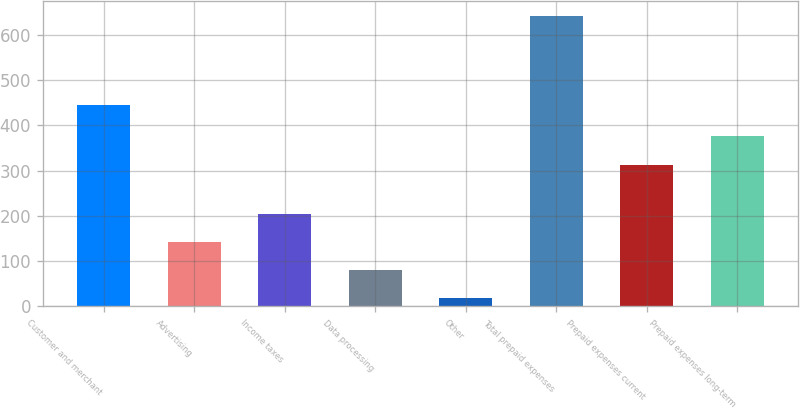<chart> <loc_0><loc_0><loc_500><loc_500><bar_chart><fcel>Customer and merchant<fcel>Advertising<fcel>Income taxes<fcel>Data processing<fcel>Other<fcel>Total prepaid expenses<fcel>Prepaid expenses current<fcel>Prepaid expenses long-term<nl><fcel>445<fcel>142.6<fcel>204.9<fcel>80.3<fcel>18<fcel>641<fcel>313<fcel>375.3<nl></chart> 